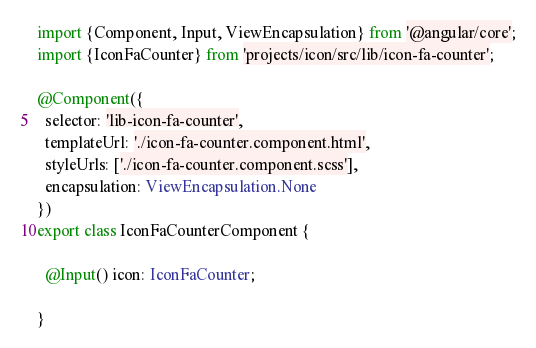<code> <loc_0><loc_0><loc_500><loc_500><_TypeScript_>import {Component, Input, ViewEncapsulation} from '@angular/core';
import {IconFaCounter} from 'projects/icon/src/lib/icon-fa-counter';

@Component({
  selector: 'lib-icon-fa-counter',
  templateUrl: './icon-fa-counter.component.html',
  styleUrls: ['./icon-fa-counter.component.scss'],
  encapsulation: ViewEncapsulation.None
})
export class IconFaCounterComponent {

  @Input() icon: IconFaCounter;

}
</code> 